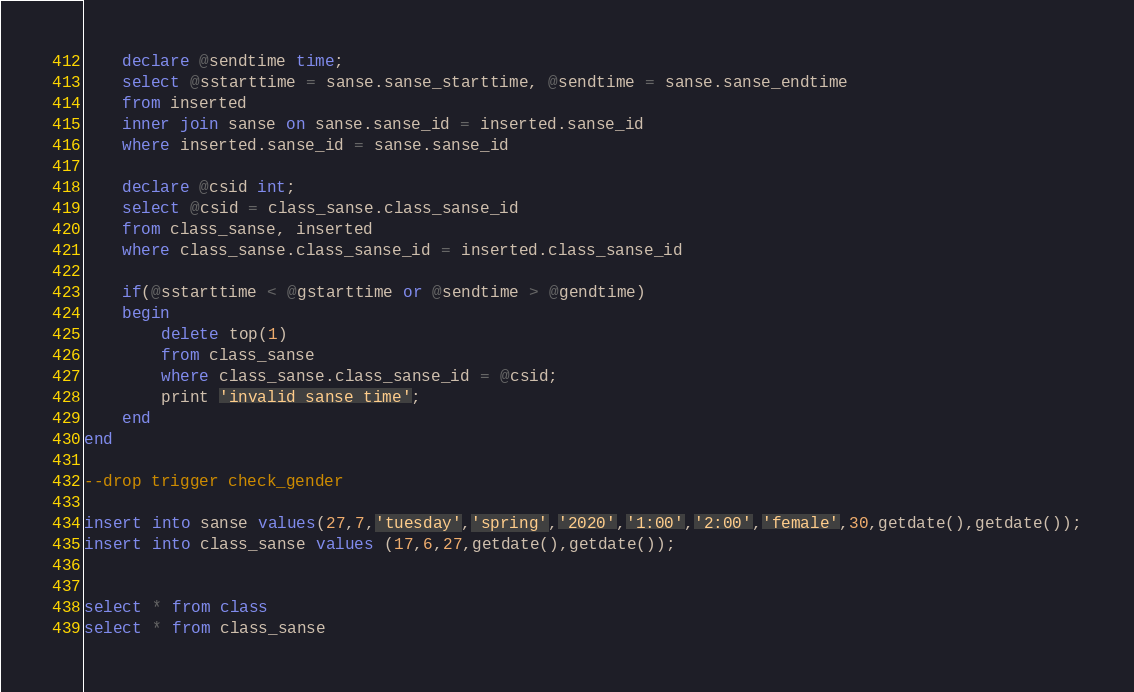<code> <loc_0><loc_0><loc_500><loc_500><_SQL_>	declare @sendtime time;
	select @sstarttime = sanse.sanse_starttime, @sendtime = sanse.sanse_endtime
	from inserted
	inner join sanse on sanse.sanse_id = inserted.sanse_id
	where inserted.sanse_id = sanse.sanse_id

	declare @csid int;
	select @csid = class_sanse.class_sanse_id
	from class_sanse, inserted
	where class_sanse.class_sanse_id = inserted.class_sanse_id

	if(@sstarttime < @gstarttime or @sendtime > @gendtime)
	begin
		delete top(1)
		from class_sanse
		where class_sanse.class_sanse_id = @csid;
		print 'invalid sanse time';
	end
end

--drop trigger check_gender

insert into sanse values(27,7,'tuesday','spring','2020','1:00','2:00','female',30,getdate(),getdate());
insert into class_sanse values (17,6,27,getdate(),getdate());


select * from class
select * from class_sanse
</code> 